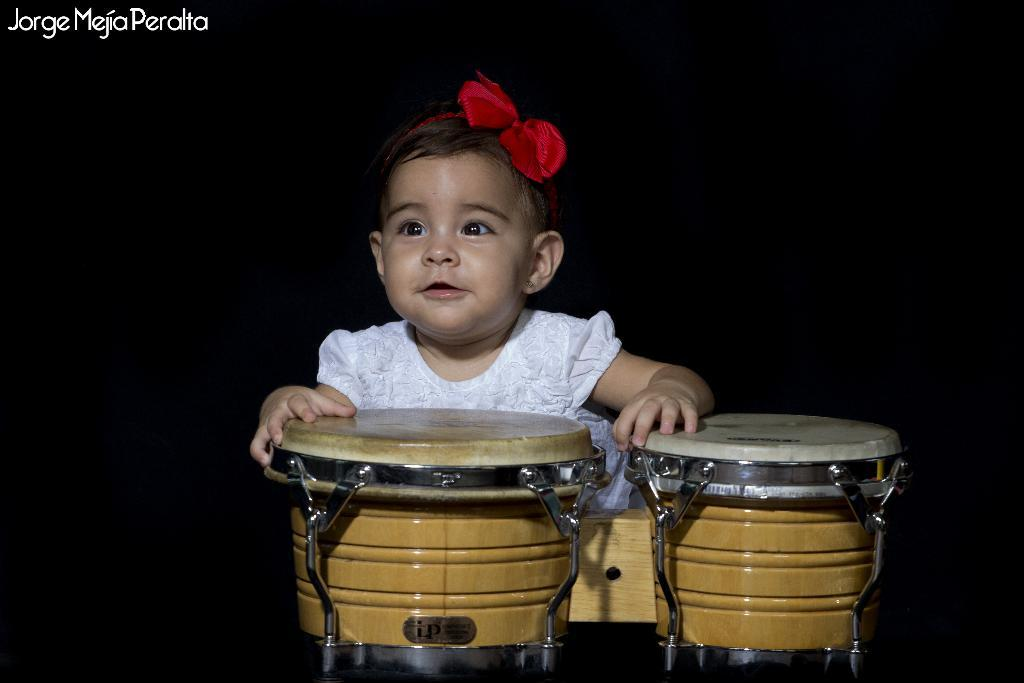What is the main subject of the image? The main subject of the image is a kid. Can you describe the kid's attire? The kid is wearing a white dress. How is the kid being emphasized in the image? The kid is highlighted in the image. What objects are in front of the kid? There are 2 musical drums in front of the kid. What type of plantation can be seen in the background of the image? There is no plantation visible in the image. What sign is present near the kid in the image? There is no sign present near the kid in the image. 